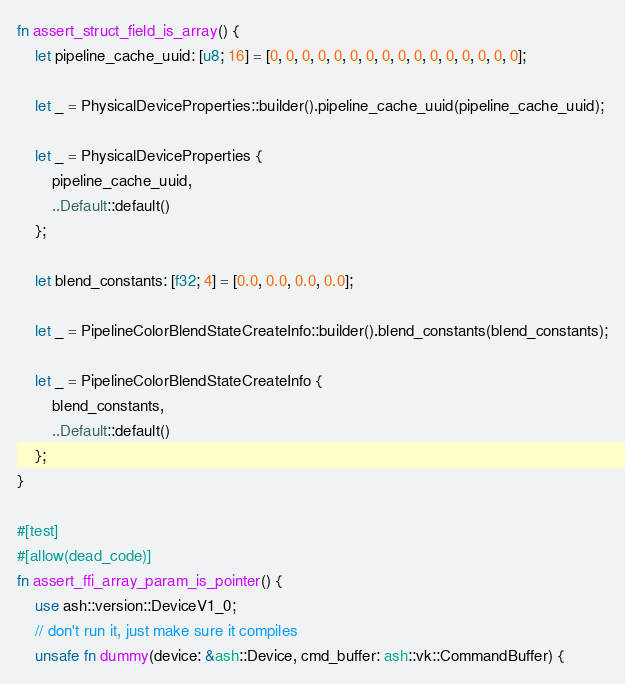<code> <loc_0><loc_0><loc_500><loc_500><_Rust_>fn assert_struct_field_is_array() {
    let pipeline_cache_uuid: [u8; 16] = [0, 0, 0, 0, 0, 0, 0, 0, 0, 0, 0, 0, 0, 0, 0, 0];

    let _ = PhysicalDeviceProperties::builder().pipeline_cache_uuid(pipeline_cache_uuid);

    let _ = PhysicalDeviceProperties {
        pipeline_cache_uuid,
        ..Default::default()
    };

    let blend_constants: [f32; 4] = [0.0, 0.0, 0.0, 0.0];

    let _ = PipelineColorBlendStateCreateInfo::builder().blend_constants(blend_constants);

    let _ = PipelineColorBlendStateCreateInfo {
        blend_constants,
        ..Default::default()
    };
}

#[test]
#[allow(dead_code)]
fn assert_ffi_array_param_is_pointer() {
    use ash::version::DeviceV1_0;
    // don't run it, just make sure it compiles
    unsafe fn dummy(device: &ash::Device, cmd_buffer: ash::vk::CommandBuffer) {</code> 